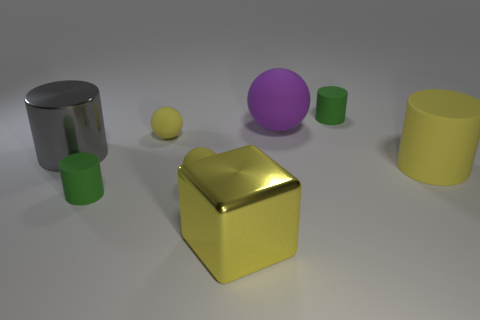Are the small cylinder behind the large yellow cylinder and the large yellow block made of the same material?
Give a very brief answer. No. What number of cubes are either purple things or small rubber things?
Make the answer very short. 0. What shape is the large object that is both in front of the gray shiny thing and on the left side of the big yellow cylinder?
Provide a succinct answer. Cube. There is a big rubber thing that is right of the small green matte thing behind the large shiny thing that is behind the big yellow shiny object; what color is it?
Provide a succinct answer. Yellow. Are there fewer big metal cylinders to the right of the big gray metallic cylinder than blue things?
Offer a very short reply. No. There is a small green object to the right of the yellow metallic object; does it have the same shape as the big thing that is on the right side of the purple matte object?
Give a very brief answer. Yes. How many things are either things that are to the left of the purple thing or tiny green rubber things?
Offer a very short reply. 6. What is the material of the big thing that is the same color as the big matte cylinder?
Provide a short and direct response. Metal. There is a green object on the right side of the tiny rubber cylinder that is in front of the gray metal thing; is there a tiny rubber thing that is right of it?
Give a very brief answer. No. Is the number of small yellow objects to the left of the big rubber cylinder less than the number of gray metal cylinders to the right of the yellow metal object?
Offer a very short reply. No. 